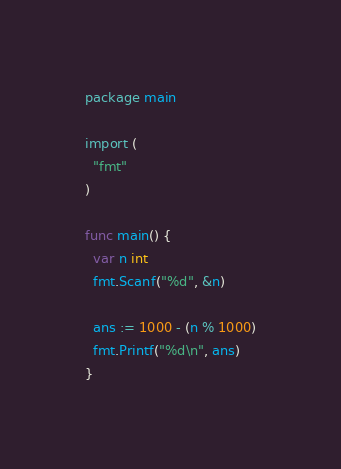Convert code to text. <code><loc_0><loc_0><loc_500><loc_500><_Go_>package main

import (
  "fmt"
)

func main() {
  var n int
  fmt.Scanf("%d", &n)
  
  ans := 1000 - (n % 1000)
  fmt.Printf("%d\n", ans)
}</code> 